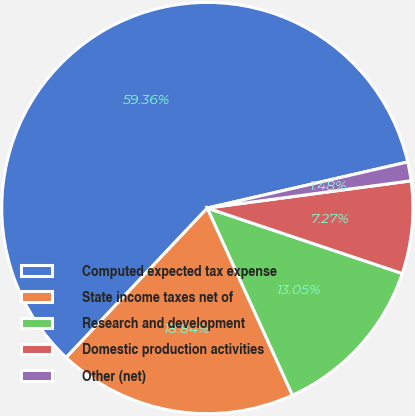Convert chart to OTSL. <chart><loc_0><loc_0><loc_500><loc_500><pie_chart><fcel>Computed expected tax expense<fcel>State income taxes net of<fcel>Research and development<fcel>Domestic production activities<fcel>Other (net)<nl><fcel>59.36%<fcel>18.84%<fcel>13.05%<fcel>7.27%<fcel>1.48%<nl></chart> 